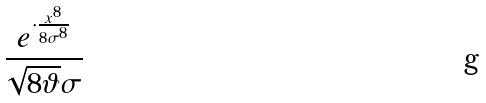<formula> <loc_0><loc_0><loc_500><loc_500>\frac { e ^ { \cdot \frac { x ^ { 8 } } { 8 \sigma ^ { 8 } } } } { \sqrt { 8 \vartheta } \sigma }</formula> 